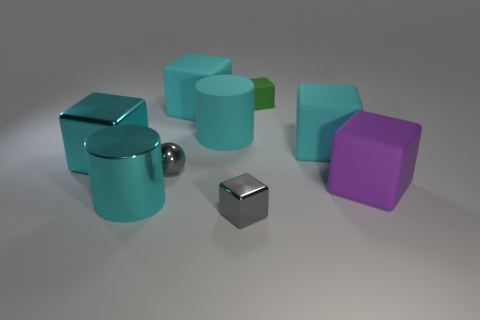How many cyan cubes must be subtracted to get 1 cyan cubes? 2 Subtract all blue cylinders. How many cyan cubes are left? 3 Subtract all gray cubes. How many cubes are left? 5 Subtract 2 cubes. How many cubes are left? 4 Subtract all big purple rubber cubes. How many cubes are left? 5 Subtract all purple blocks. Subtract all brown cylinders. How many blocks are left? 5 Subtract all cylinders. How many objects are left? 7 Subtract all cyan matte things. Subtract all tiny gray metallic things. How many objects are left? 4 Add 5 tiny cubes. How many tiny cubes are left? 7 Add 6 tiny gray balls. How many tiny gray balls exist? 7 